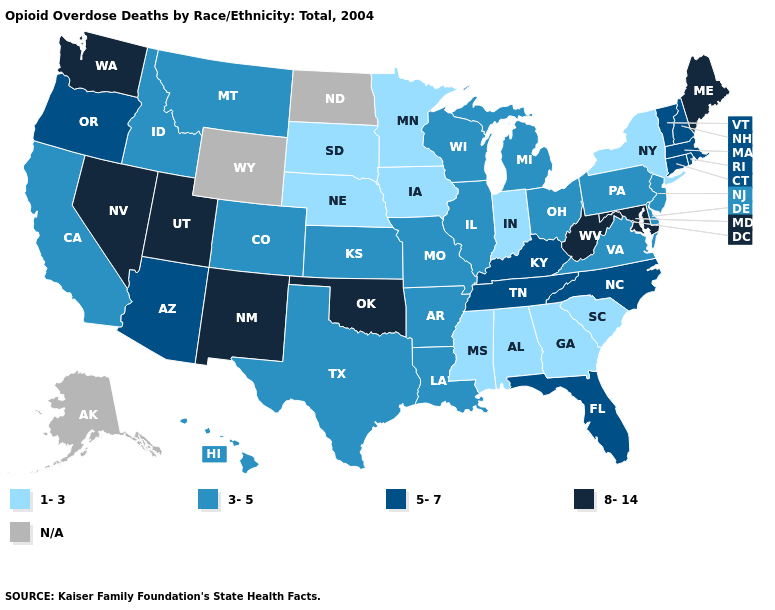Among the states that border Rhode Island , which have the lowest value?
Give a very brief answer. Connecticut, Massachusetts. Does South Carolina have the lowest value in the South?
Answer briefly. Yes. Does Tennessee have the lowest value in the South?
Quick response, please. No. What is the value of Massachusetts?
Write a very short answer. 5-7. Name the states that have a value in the range 5-7?
Short answer required. Arizona, Connecticut, Florida, Kentucky, Massachusetts, New Hampshire, North Carolina, Oregon, Rhode Island, Tennessee, Vermont. What is the value of California?
Write a very short answer. 3-5. What is the value of Florida?
Write a very short answer. 5-7. How many symbols are there in the legend?
Short answer required. 5. What is the value of Wyoming?
Quick response, please. N/A. Name the states that have a value in the range 1-3?
Concise answer only. Alabama, Georgia, Indiana, Iowa, Minnesota, Mississippi, Nebraska, New York, South Carolina, South Dakota. What is the highest value in the USA?
Give a very brief answer. 8-14. What is the value of Massachusetts?
Short answer required. 5-7. 